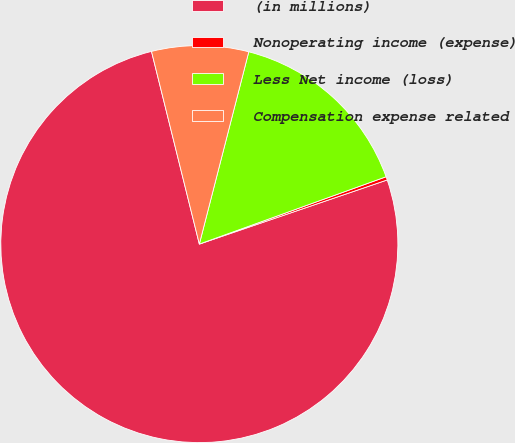Convert chart to OTSL. <chart><loc_0><loc_0><loc_500><loc_500><pie_chart><fcel>(in millions)<fcel>Nonoperating income (expense)<fcel>Less Net income (loss)<fcel>Compensation expense related<nl><fcel>76.37%<fcel>0.27%<fcel>15.49%<fcel>7.88%<nl></chart> 